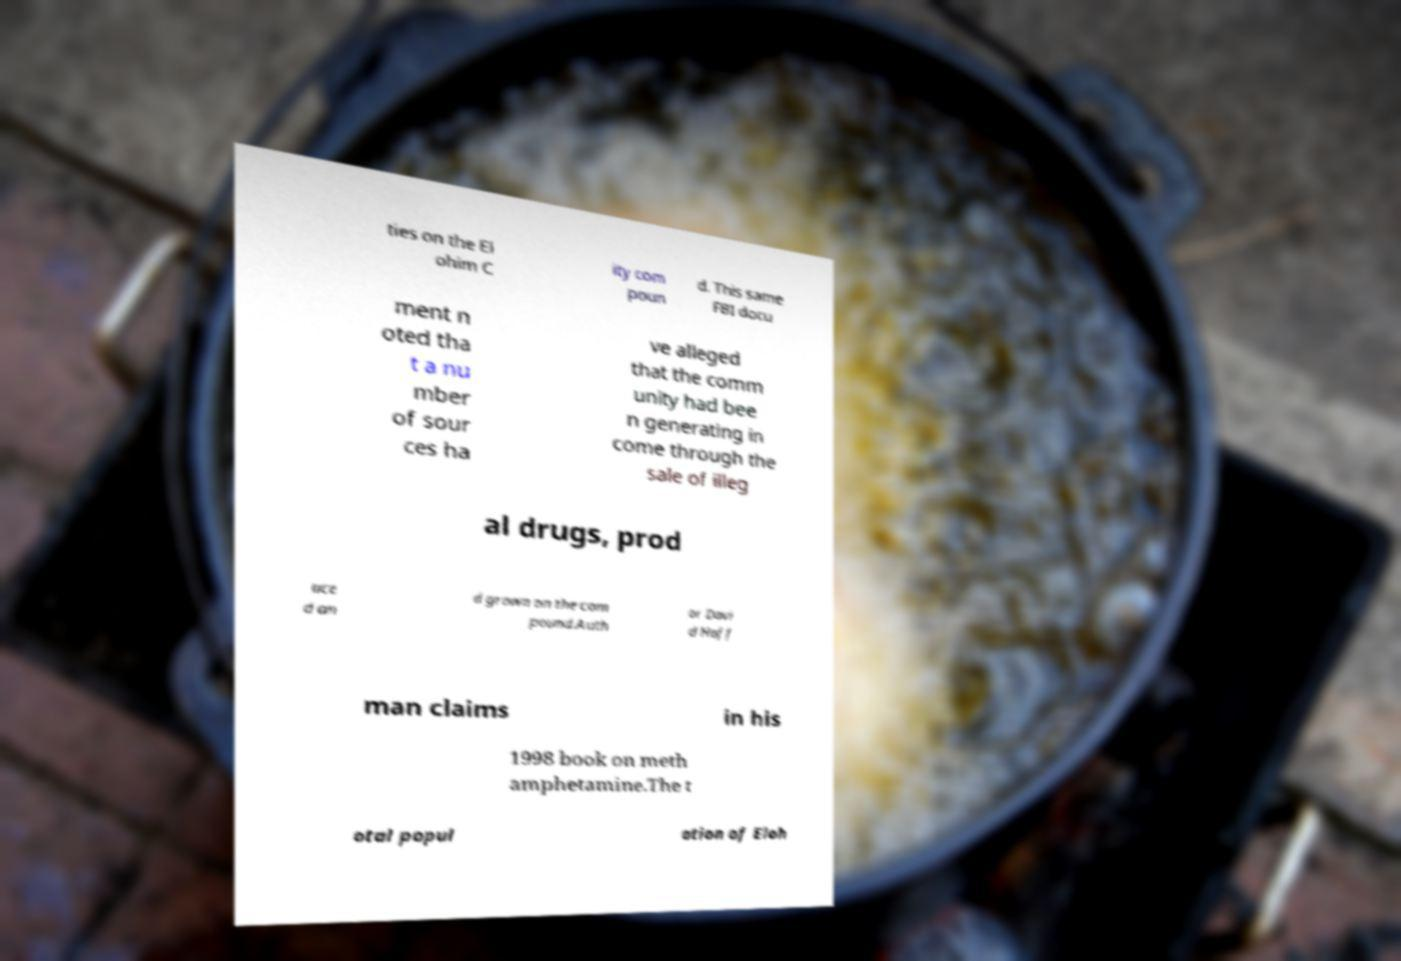Please read and relay the text visible in this image. What does it say? ties on the El ohim C ity com poun d. This same FBI docu ment n oted tha t a nu mber of sour ces ha ve alleged that the comm unity had bee n generating in come through the sale of illeg al drugs, prod uce d an d grown on the com pound.Auth or Davi d Hoff man claims in his 1998 book on meth amphetamine.The t otal popul ation of Eloh 